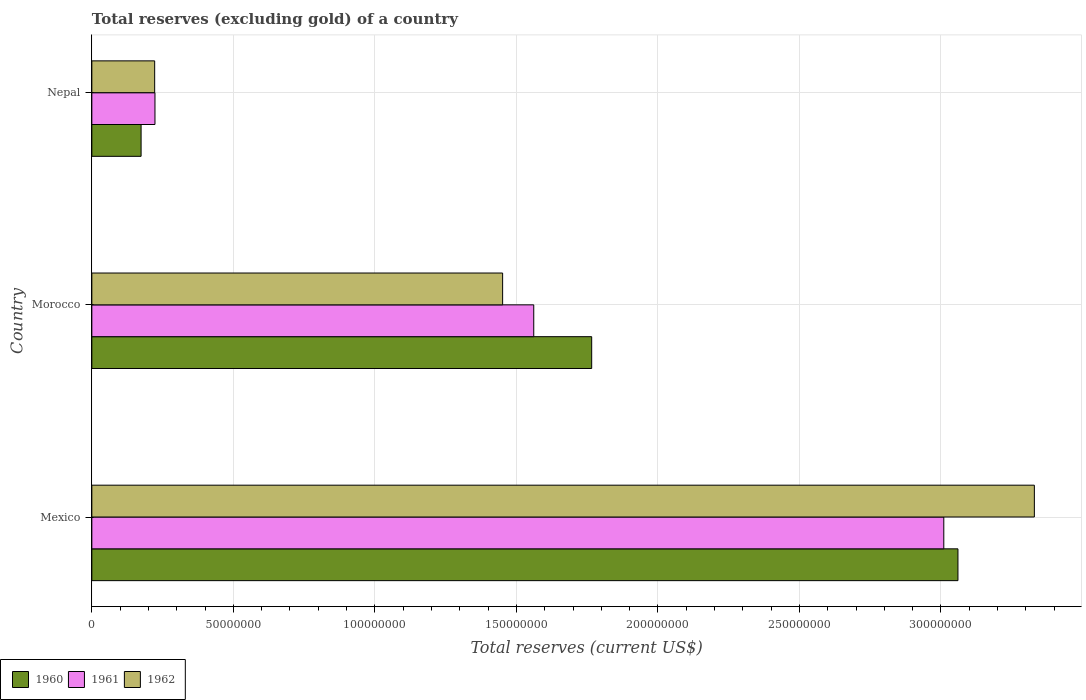How many groups of bars are there?
Your answer should be very brief. 3. Are the number of bars on each tick of the Y-axis equal?
Keep it short and to the point. Yes. What is the label of the 1st group of bars from the top?
Give a very brief answer. Nepal. What is the total reserves (excluding gold) in 1960 in Morocco?
Provide a short and direct response. 1.77e+08. Across all countries, what is the maximum total reserves (excluding gold) in 1960?
Offer a terse response. 3.06e+08. Across all countries, what is the minimum total reserves (excluding gold) in 1960?
Give a very brief answer. 1.74e+07. In which country was the total reserves (excluding gold) in 1960 minimum?
Give a very brief answer. Nepal. What is the total total reserves (excluding gold) in 1960 in the graph?
Offer a very short reply. 5.00e+08. What is the difference between the total reserves (excluding gold) in 1960 in Mexico and that in Morocco?
Your answer should be compact. 1.29e+08. What is the difference between the total reserves (excluding gold) in 1961 in Nepal and the total reserves (excluding gold) in 1962 in Morocco?
Give a very brief answer. -1.23e+08. What is the average total reserves (excluding gold) in 1961 per country?
Your response must be concise. 1.60e+08. What is the difference between the total reserves (excluding gold) in 1961 and total reserves (excluding gold) in 1960 in Nepal?
Your answer should be compact. 4.90e+06. What is the ratio of the total reserves (excluding gold) in 1960 in Mexico to that in Nepal?
Provide a short and direct response. 17.59. Is the difference between the total reserves (excluding gold) in 1961 in Mexico and Morocco greater than the difference between the total reserves (excluding gold) in 1960 in Mexico and Morocco?
Give a very brief answer. Yes. What is the difference between the highest and the second highest total reserves (excluding gold) in 1961?
Give a very brief answer. 1.45e+08. What is the difference between the highest and the lowest total reserves (excluding gold) in 1962?
Provide a short and direct response. 3.11e+08. In how many countries, is the total reserves (excluding gold) in 1960 greater than the average total reserves (excluding gold) in 1960 taken over all countries?
Your answer should be compact. 2. What does the 2nd bar from the top in Morocco represents?
Keep it short and to the point. 1961. What does the 1st bar from the bottom in Nepal represents?
Provide a succinct answer. 1960. How many bars are there?
Ensure brevity in your answer.  9. What is the difference between two consecutive major ticks on the X-axis?
Ensure brevity in your answer.  5.00e+07. Are the values on the major ticks of X-axis written in scientific E-notation?
Give a very brief answer. No. Does the graph contain any zero values?
Offer a terse response. No. How many legend labels are there?
Ensure brevity in your answer.  3. What is the title of the graph?
Offer a very short reply. Total reserves (excluding gold) of a country. Does "1995" appear as one of the legend labels in the graph?
Offer a terse response. No. What is the label or title of the X-axis?
Provide a succinct answer. Total reserves (current US$). What is the label or title of the Y-axis?
Provide a succinct answer. Country. What is the Total reserves (current US$) of 1960 in Mexico?
Keep it short and to the point. 3.06e+08. What is the Total reserves (current US$) in 1961 in Mexico?
Your answer should be compact. 3.01e+08. What is the Total reserves (current US$) of 1962 in Mexico?
Make the answer very short. 3.33e+08. What is the Total reserves (current US$) in 1960 in Morocco?
Provide a succinct answer. 1.77e+08. What is the Total reserves (current US$) in 1961 in Morocco?
Provide a succinct answer. 1.56e+08. What is the Total reserves (current US$) in 1962 in Morocco?
Provide a short and direct response. 1.45e+08. What is the Total reserves (current US$) in 1960 in Nepal?
Give a very brief answer. 1.74e+07. What is the Total reserves (current US$) in 1961 in Nepal?
Your response must be concise. 2.23e+07. What is the Total reserves (current US$) of 1962 in Nepal?
Keep it short and to the point. 2.22e+07. Across all countries, what is the maximum Total reserves (current US$) in 1960?
Your answer should be very brief. 3.06e+08. Across all countries, what is the maximum Total reserves (current US$) in 1961?
Give a very brief answer. 3.01e+08. Across all countries, what is the maximum Total reserves (current US$) of 1962?
Your response must be concise. 3.33e+08. Across all countries, what is the minimum Total reserves (current US$) in 1960?
Provide a short and direct response. 1.74e+07. Across all countries, what is the minimum Total reserves (current US$) of 1961?
Your response must be concise. 2.23e+07. Across all countries, what is the minimum Total reserves (current US$) in 1962?
Ensure brevity in your answer.  2.22e+07. What is the total Total reserves (current US$) in 1960 in the graph?
Keep it short and to the point. 5.00e+08. What is the total Total reserves (current US$) of 1961 in the graph?
Offer a terse response. 4.79e+08. What is the total Total reserves (current US$) of 1962 in the graph?
Provide a succinct answer. 5.00e+08. What is the difference between the Total reserves (current US$) in 1960 in Mexico and that in Morocco?
Your answer should be compact. 1.29e+08. What is the difference between the Total reserves (current US$) of 1961 in Mexico and that in Morocco?
Your answer should be very brief. 1.45e+08. What is the difference between the Total reserves (current US$) in 1962 in Mexico and that in Morocco?
Offer a very short reply. 1.88e+08. What is the difference between the Total reserves (current US$) in 1960 in Mexico and that in Nepal?
Keep it short and to the point. 2.89e+08. What is the difference between the Total reserves (current US$) of 1961 in Mexico and that in Nepal?
Give a very brief answer. 2.79e+08. What is the difference between the Total reserves (current US$) in 1962 in Mexico and that in Nepal?
Provide a succinct answer. 3.11e+08. What is the difference between the Total reserves (current US$) in 1960 in Morocco and that in Nepal?
Your answer should be compact. 1.59e+08. What is the difference between the Total reserves (current US$) of 1961 in Morocco and that in Nepal?
Your response must be concise. 1.34e+08. What is the difference between the Total reserves (current US$) of 1962 in Morocco and that in Nepal?
Give a very brief answer. 1.23e+08. What is the difference between the Total reserves (current US$) in 1960 in Mexico and the Total reserves (current US$) in 1961 in Morocco?
Offer a very short reply. 1.50e+08. What is the difference between the Total reserves (current US$) in 1960 in Mexico and the Total reserves (current US$) in 1962 in Morocco?
Offer a very short reply. 1.61e+08. What is the difference between the Total reserves (current US$) in 1961 in Mexico and the Total reserves (current US$) in 1962 in Morocco?
Your response must be concise. 1.56e+08. What is the difference between the Total reserves (current US$) of 1960 in Mexico and the Total reserves (current US$) of 1961 in Nepal?
Offer a very short reply. 2.84e+08. What is the difference between the Total reserves (current US$) in 1960 in Mexico and the Total reserves (current US$) in 1962 in Nepal?
Make the answer very short. 2.84e+08. What is the difference between the Total reserves (current US$) of 1961 in Mexico and the Total reserves (current US$) of 1962 in Nepal?
Offer a very short reply. 2.79e+08. What is the difference between the Total reserves (current US$) in 1960 in Morocco and the Total reserves (current US$) in 1961 in Nepal?
Your answer should be compact. 1.54e+08. What is the difference between the Total reserves (current US$) in 1960 in Morocco and the Total reserves (current US$) in 1962 in Nepal?
Give a very brief answer. 1.54e+08. What is the difference between the Total reserves (current US$) of 1961 in Morocco and the Total reserves (current US$) of 1962 in Nepal?
Give a very brief answer. 1.34e+08. What is the average Total reserves (current US$) in 1960 per country?
Offer a very short reply. 1.67e+08. What is the average Total reserves (current US$) in 1961 per country?
Your answer should be very brief. 1.60e+08. What is the average Total reserves (current US$) in 1962 per country?
Offer a terse response. 1.67e+08. What is the difference between the Total reserves (current US$) of 1960 and Total reserves (current US$) of 1961 in Mexico?
Make the answer very short. 5.00e+06. What is the difference between the Total reserves (current US$) of 1960 and Total reserves (current US$) of 1962 in Mexico?
Provide a succinct answer. -2.70e+07. What is the difference between the Total reserves (current US$) in 1961 and Total reserves (current US$) in 1962 in Mexico?
Keep it short and to the point. -3.20e+07. What is the difference between the Total reserves (current US$) in 1960 and Total reserves (current US$) in 1961 in Morocco?
Your answer should be very brief. 2.05e+07. What is the difference between the Total reserves (current US$) in 1960 and Total reserves (current US$) in 1962 in Morocco?
Offer a terse response. 3.15e+07. What is the difference between the Total reserves (current US$) of 1961 and Total reserves (current US$) of 1962 in Morocco?
Keep it short and to the point. 1.10e+07. What is the difference between the Total reserves (current US$) in 1960 and Total reserves (current US$) in 1961 in Nepal?
Ensure brevity in your answer.  -4.90e+06. What is the difference between the Total reserves (current US$) in 1960 and Total reserves (current US$) in 1962 in Nepal?
Offer a very short reply. -4.80e+06. What is the difference between the Total reserves (current US$) in 1961 and Total reserves (current US$) in 1962 in Nepal?
Provide a short and direct response. 1.00e+05. What is the ratio of the Total reserves (current US$) of 1960 in Mexico to that in Morocco?
Make the answer very short. 1.73. What is the ratio of the Total reserves (current US$) of 1961 in Mexico to that in Morocco?
Ensure brevity in your answer.  1.93. What is the ratio of the Total reserves (current US$) in 1962 in Mexico to that in Morocco?
Your answer should be compact. 2.29. What is the ratio of the Total reserves (current US$) in 1960 in Mexico to that in Nepal?
Give a very brief answer. 17.59. What is the ratio of the Total reserves (current US$) of 1961 in Mexico to that in Nepal?
Provide a succinct answer. 13.5. What is the ratio of the Total reserves (current US$) in 1962 in Mexico to that in Nepal?
Offer a terse response. 15. What is the ratio of the Total reserves (current US$) in 1960 in Morocco to that in Nepal?
Offer a very short reply. 10.15. What is the ratio of the Total reserves (current US$) of 1961 in Morocco to that in Nepal?
Keep it short and to the point. 7. What is the ratio of the Total reserves (current US$) in 1962 in Morocco to that in Nepal?
Your response must be concise. 6.54. What is the difference between the highest and the second highest Total reserves (current US$) of 1960?
Your response must be concise. 1.29e+08. What is the difference between the highest and the second highest Total reserves (current US$) in 1961?
Make the answer very short. 1.45e+08. What is the difference between the highest and the second highest Total reserves (current US$) in 1962?
Your answer should be very brief. 1.88e+08. What is the difference between the highest and the lowest Total reserves (current US$) in 1960?
Your response must be concise. 2.89e+08. What is the difference between the highest and the lowest Total reserves (current US$) in 1961?
Make the answer very short. 2.79e+08. What is the difference between the highest and the lowest Total reserves (current US$) of 1962?
Provide a succinct answer. 3.11e+08. 